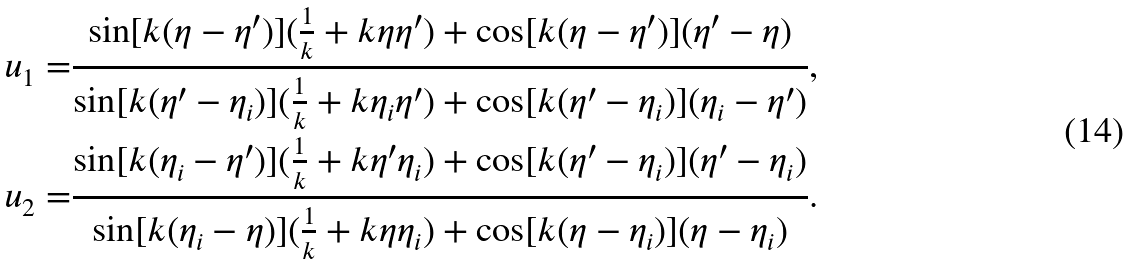<formula> <loc_0><loc_0><loc_500><loc_500>u _ { 1 } = & \frac { \sin [ k ( \eta - \eta ^ { \prime } ) ] ( \frac { 1 } { k } + k \eta \eta ^ { \prime } ) + \cos [ k ( \eta - \eta ^ { \prime } ) ] ( \eta ^ { \prime } - \eta ) } { \sin [ k ( \eta ^ { \prime } - \eta _ { i } ) ] ( \frac { 1 } { k } + k \eta _ { i } \eta ^ { \prime } ) + \cos [ k ( \eta ^ { \prime } - \eta _ { i } ) ] ( \eta _ { i } - \eta ^ { \prime } ) } , \\ u _ { 2 } = & \frac { \sin [ k ( \eta _ { i } - \eta ^ { \prime } ) ] ( \frac { 1 } { k } + k \eta ^ { \prime } \eta _ { i } ) + \cos [ k ( \eta ^ { \prime } - \eta _ { i } ) ] ( \eta ^ { \prime } - \eta _ { i } ) } { \sin [ k ( \eta _ { i } - \eta ) ] ( \frac { 1 } { k } + k \eta \eta _ { i } ) + \cos [ k ( \eta - \eta _ { i } ) ] ( \eta - \eta _ { i } ) } .</formula> 